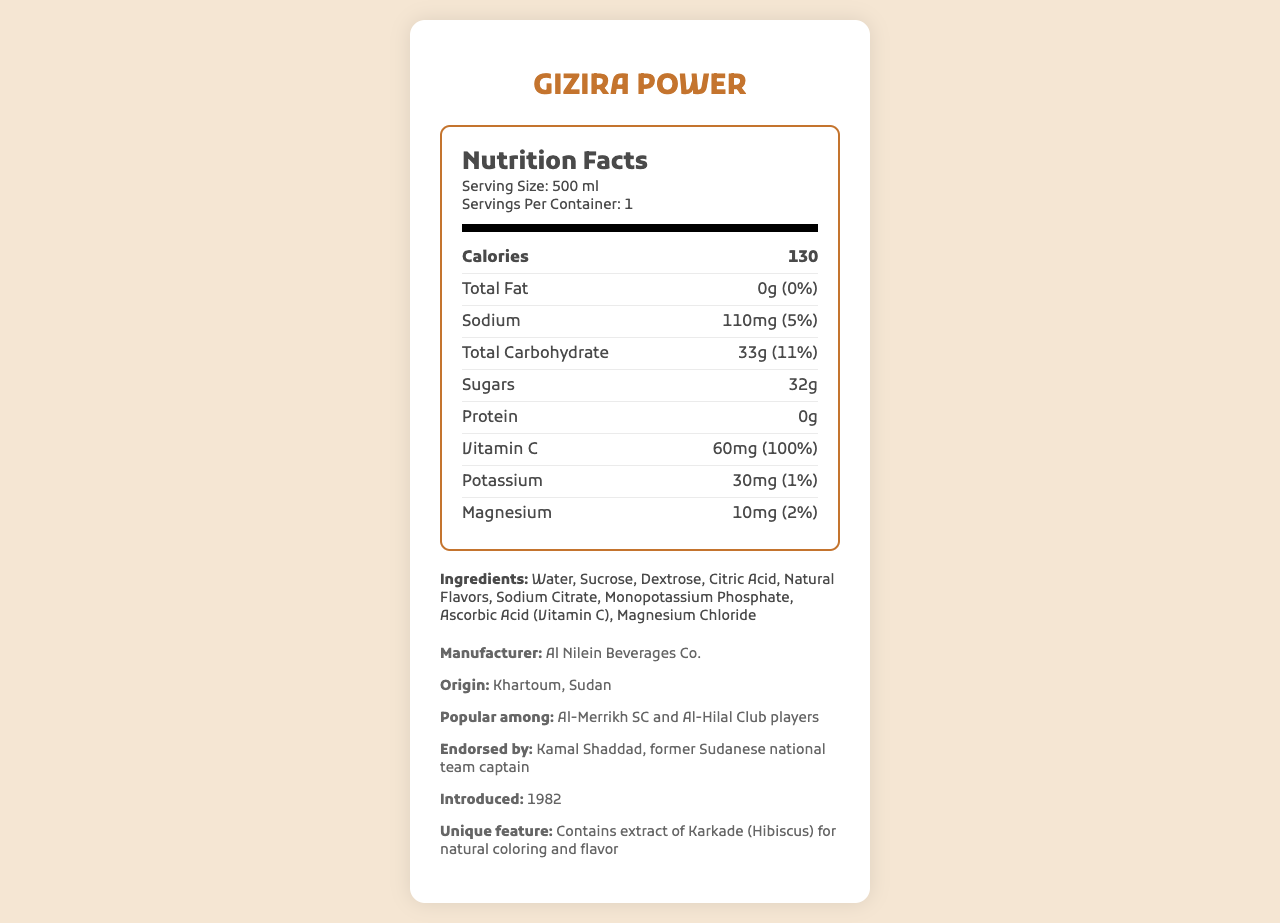Who manufactures Gizira Power? The manufacturer information is clearly stated under the additional info section of the document.
Answer: Al Nilein Beverages Co. What is the serving size of Gizira Power? The serving size is mentioned at the top of the nutrition label.
Answer: 500 ml How many calories are there per serving in Gizira Power? The calorie content per serving is found in the bolded nutrient row within the nutrition facts section.
Answer: 130 How much vitamin C does one serving contain? The vitamin C content is listed in the nutrient rows under the nutrition facts label.
Answer: 60 mg What is the percentage of the daily value for sodium in one serving? The percentage daily value for sodium is stated next to its amount in the nutrient row.
Answer: 5% Who is Gizira Power endorsed by? The endorsement information is given in the additional info section.
Answer: Kamal Shaddad, former Sudanese national team captain Which of the following is not an ingredient in Gizira Power? A. Sucrose B. Glucose C. Citric Acid The ingredients listed include sucrose and citric acid, but not glucose.
Answer: B. Glucose When was Gizira Power introduced? A. 1972 B. 1982 C. 1992 The introduction year of the product is provided in the additional info section.
Answer: B. 1982 Is there any protein in Gizira Power? The protein content is listed as 0g.
Answer: No Describe the main features of the Gizira Power nutrition label. The explanation gives an overview of the main aspects of the product's nutrition and additional information such as popularity and endorsement details.
Answer: Gizira Power is a sports drink with a serving size of 500 ml, containing 130 calories per serving. It has 0g total fat, 110mg sodium, 33g total carbohydrates, including 32g of sugars, and 0g protein. It is fortified with 60mg of vitamin C (100% daily value), as well as potassium and magnesium. The drink is popular among Al-Merrikh SC and Al-Hilal Club players and endorsed by Kamal Shaddad. How much potassium is in one serving of Gizira Power? The amount of potassium is listed in the nutrient rows under the nutrition facts label.
Answer: 30mg Does Gizira Power contain any artificial colors? The document mentions that it uses extract of Karkade (Hibiscus) for natural coloring.
Answer: No What is the total carbohydrate content in one serving? The total carbohydrate content is specified in the nutrient rows of the nutrition facts label.
Answer: 33g Where is Gizira Power manufactured? The origin of the product is provided in the additional info section.
Answer: Khartoum, Sudan Which club's players are noted as consumers of Gizira Power? A. Al-Ahly B. Al-Merrikh SC C. Manchester United The document specifies that Al-Merrikh SC and Al-Hilal Club players are among its consumers.
Answer: B. Al-Merrikh SC What is the unique feature of Gizira Power? The unique feature is highlighted in the additional info section.
Answer: Contains extract of Karkade (Hibiscus) for natural coloring and flavor How much magnesium does one serving of Gizira Power contain? The magnesium content is listed in the nutrient rows of the nutrition facts label.
Answer: 10mg Can we determine the price of Gizira Power from this document? The document does not provide any information about the price of the product.
Answer: Not enough information 